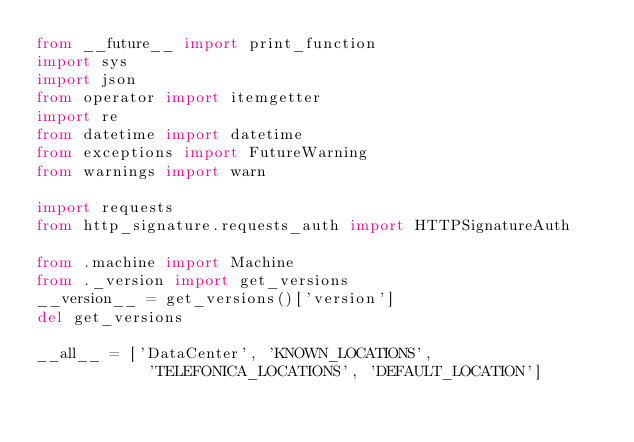<code> <loc_0><loc_0><loc_500><loc_500><_Python_>from __future__ import print_function
import sys
import json
from operator import itemgetter
import re
from datetime import datetime
from exceptions import FutureWarning
from warnings import warn

import requests
from http_signature.requests_auth import HTTPSignatureAuth

from .machine import Machine
from ._version import get_versions
__version__ = get_versions()['version']
del get_versions

__all__ = ['DataCenter', 'KNOWN_LOCATIONS', 
            'TELEFONICA_LOCATIONS', 'DEFAULT_LOCATION']
</code> 